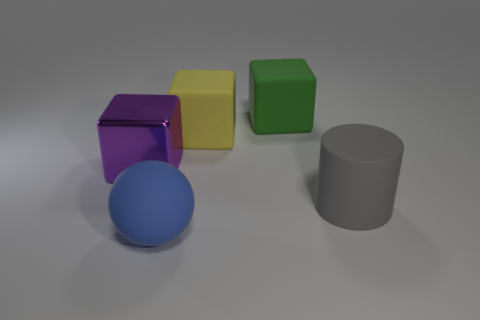What number of other objects are there of the same material as the green block?
Your response must be concise. 3. What is the shape of the object that is left of the rubber object in front of the big gray thing?
Your response must be concise. Cube. How many objects are shiny blocks or things that are to the right of the big metal cube?
Make the answer very short. 5. How many other things are the same color as the big sphere?
Provide a short and direct response. 0. What number of cyan things are either matte objects or matte cylinders?
Your answer should be very brief. 0. Is there a rubber block in front of the matte object right of the big matte thing behind the big yellow cube?
Provide a short and direct response. No. Are there any other things that are the same size as the shiny thing?
Your answer should be compact. Yes. Does the ball have the same color as the cylinder?
Make the answer very short. No. There is a big block left of the big matte object in front of the large rubber cylinder; what color is it?
Offer a very short reply. Purple. What number of small objects are either purple things or blue shiny cylinders?
Provide a short and direct response. 0. 